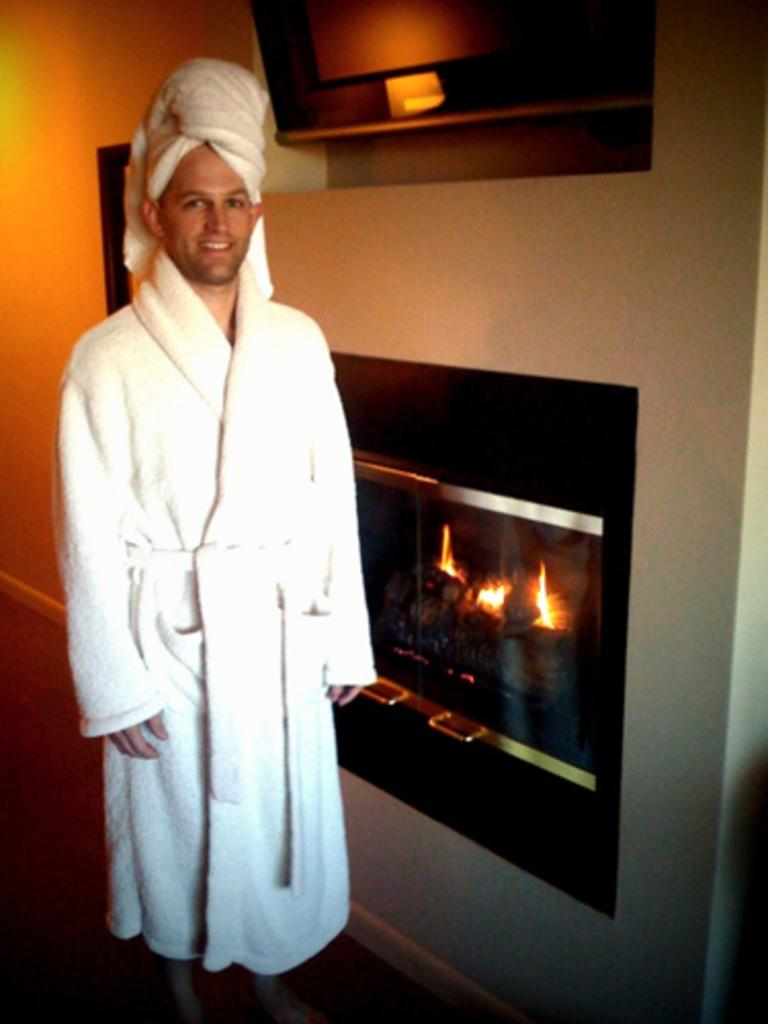Who is present in the image? There is a man in the image. What is the man's facial expression? The man is smiling. What is the man wearing? The man is wearing a towel. What can be seen in the background of the image? There is a fireplace in the background of the image. What year is depicted in the image? The image does not depict a specific year; it is a photograph of a man wearing a towel and smiling. Can you see the man's tongue in the image? No, the man's tongue is not visible in the image. 